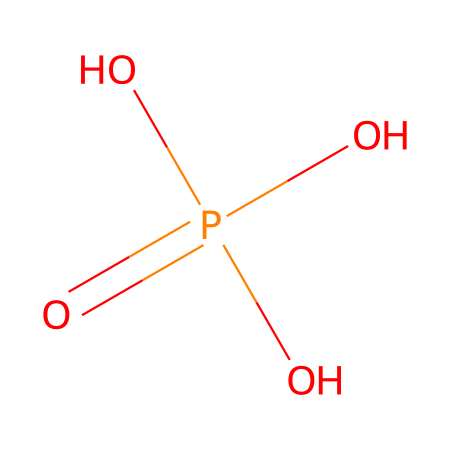What is the chemical name of this compound? The structure corresponds to the chemical formula that depicts a phosphoric acid, which is a widely recognized compound used in food and beverages.
Answer: phosphoric acid How many oxygen atoms are present in this structure? By analyzing the SMILES representation, we see there are four oxygen atoms attached to the central phosphorus atom.
Answer: four What is the oxidation state of phosphorus in this chemical? In phosphoric acid, phosphorus is bonded to three hydroxyl groups and one double bond to an oxygen atom. This suggests the oxidation state is +5 due to the counting of bonds.
Answer: +5 Does this compound behave as a strong or weak acid? Phosphoric acid is classified as a weak acid because it does not completely dissociate in a solution, releasing protons.
Answer: weak How many hydrogen atoms are in this acid? The interpretation of the SMILES representation shows there are three hydrogen atoms present attached to the hydroxyl groups.
Answer: three What role does phosphoric acid play in cola drinks? Phosphoric acid functions as a flavor enhancer and acidity regulator, providing a tangy taste to cola products.
Answer: flavor enhancer Is phosphoric acid a diprotic or triprotic acid? A triprotic acid can donate three protons to solution, which is the case with phosphoric acid due to its three acidic hydrogen atoms.
Answer: triprotic 